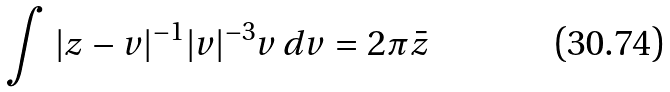<formula> <loc_0><loc_0><loc_500><loc_500>\int | z - v | ^ { - 1 } | v | ^ { - 3 } v \, d v = 2 \pi \bar { z }</formula> 